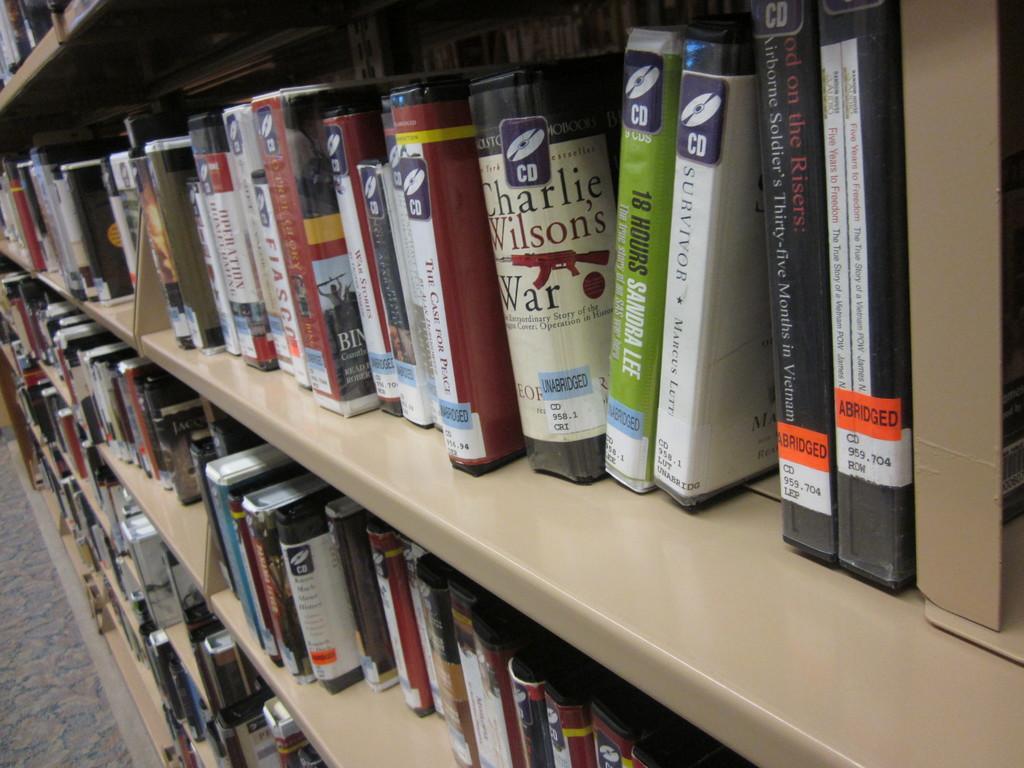Can you describe this image briefly? In the image there are different books kept in the shelves. 